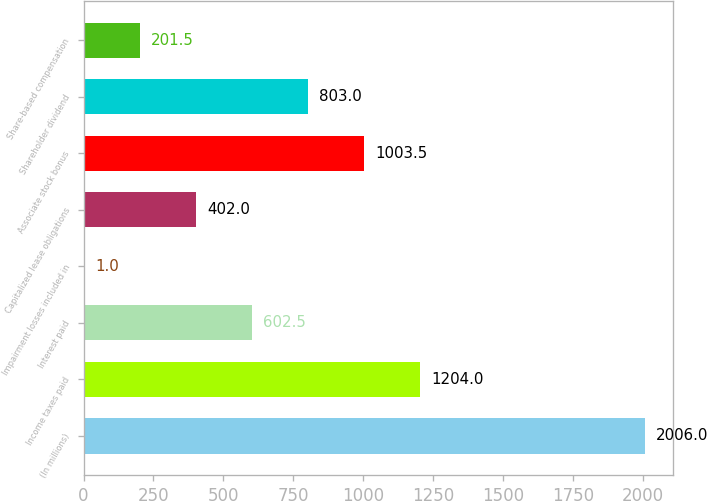Convert chart to OTSL. <chart><loc_0><loc_0><loc_500><loc_500><bar_chart><fcel>(In millions)<fcel>Income taxes paid<fcel>Interest paid<fcel>Impairment losses included in<fcel>Capitalized lease obligations<fcel>Associate stock bonus<fcel>Shareholder dividend<fcel>Share-based compensation<nl><fcel>2006<fcel>1204<fcel>602.5<fcel>1<fcel>402<fcel>1003.5<fcel>803<fcel>201.5<nl></chart> 